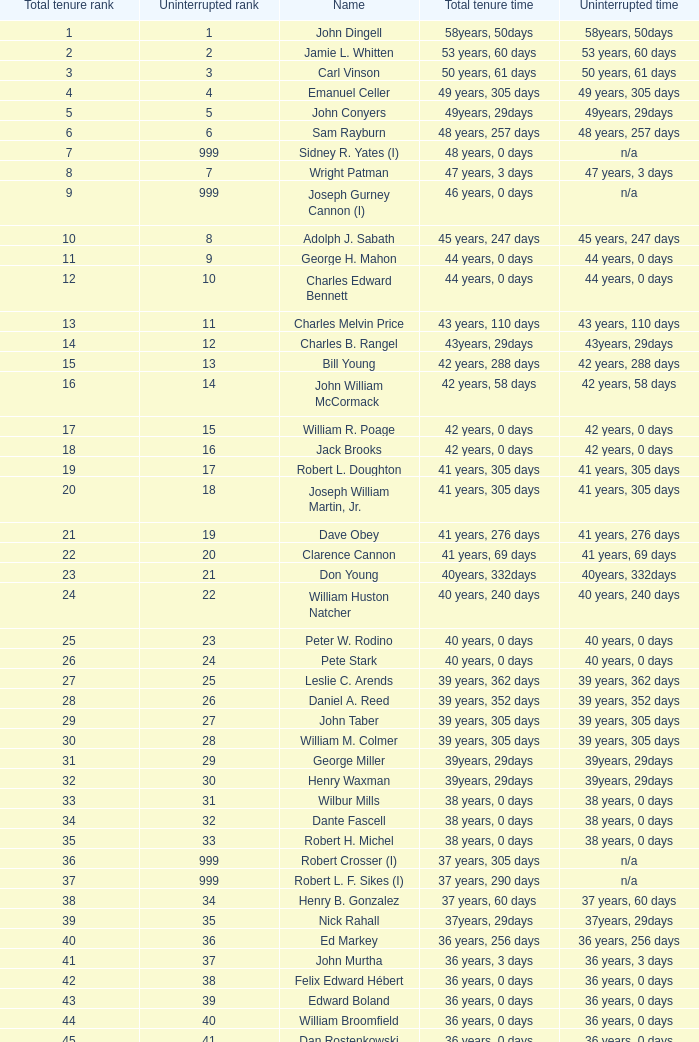Who has a complete tenure duration and continuous service period of 36 years and 0 days, along with a total tenure ranking of 49? James Oberstar. 